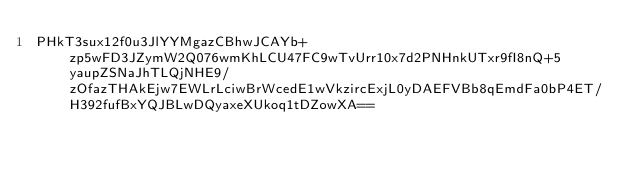<code> <loc_0><loc_0><loc_500><loc_500><_SML_>PHkT3sux12f0u3JlYYMgazCBhwJCAYb+zp5wFD3JZymW2Q076wmKhLCU47FC9wTvUrr10x7d2PNHnkUTxr9fI8nQ+5yaupZSNaJhTLQjNHE9/zOfazTHAkEjw7EWLrLciwBrWcedE1wVkzircExjL0yDAEFVBb8qEmdFa0bP4ET/H392fufBxYQJBLwDQyaxeXUkoq1tDZowXA==</code> 